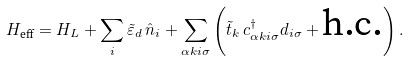Convert formula to latex. <formula><loc_0><loc_0><loc_500><loc_500>H _ { \text {eff} } = H _ { L } + \sum _ { i } \tilde { \varepsilon } _ { d } \, \hat { n } _ { i } + \sum _ { \alpha k i \sigma } \left ( \tilde { t } _ { k } \, c ^ { \dagger } _ { \alpha k i \sigma } d _ { i \sigma } + \text {h.c.} \right ) .</formula> 